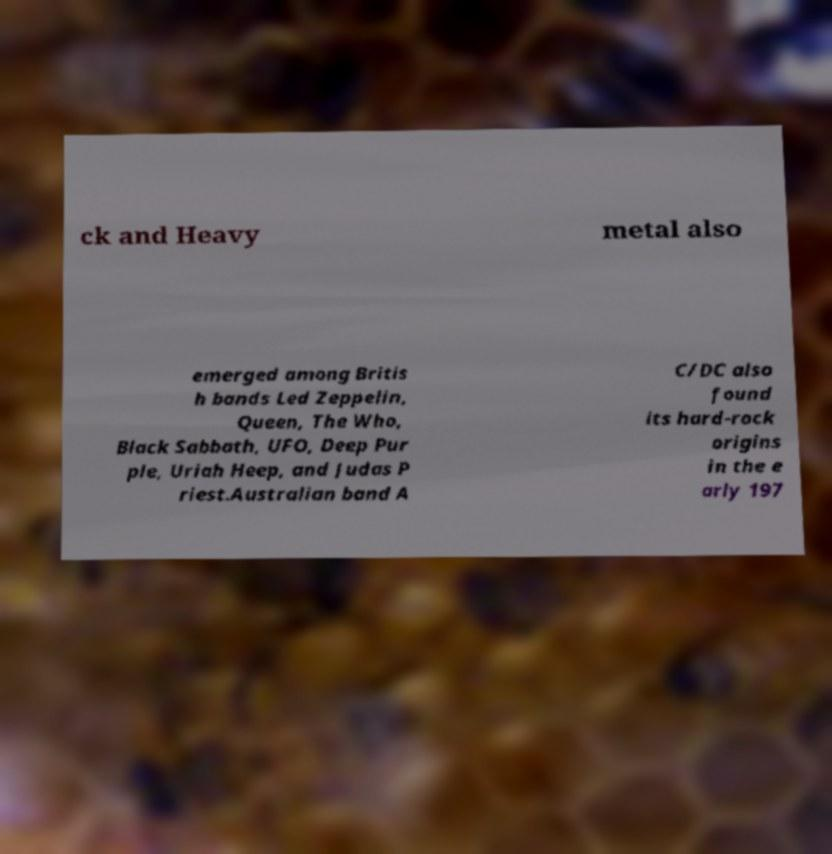Could you extract and type out the text from this image? ck and Heavy metal also emerged among Britis h bands Led Zeppelin, Queen, The Who, Black Sabbath, UFO, Deep Pur ple, Uriah Heep, and Judas P riest.Australian band A C/DC also found its hard-rock origins in the e arly 197 